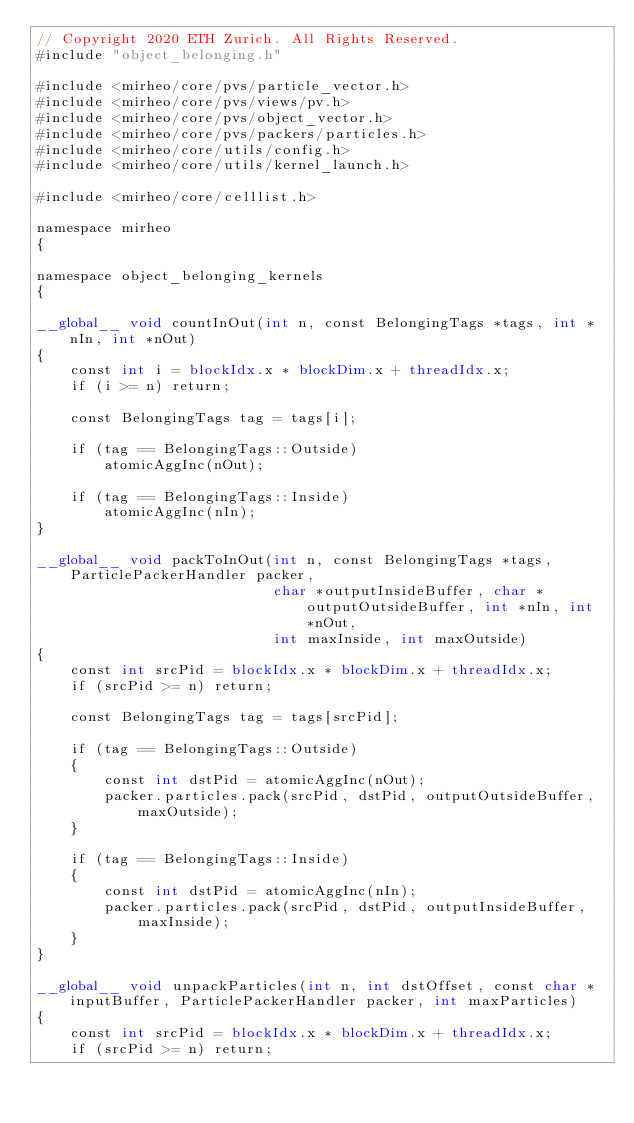<code> <loc_0><loc_0><loc_500><loc_500><_Cuda_>// Copyright 2020 ETH Zurich. All Rights Reserved.
#include "object_belonging.h"

#include <mirheo/core/pvs/particle_vector.h>
#include <mirheo/core/pvs/views/pv.h>
#include <mirheo/core/pvs/object_vector.h>
#include <mirheo/core/pvs/packers/particles.h>
#include <mirheo/core/utils/config.h>
#include <mirheo/core/utils/kernel_launch.h>

#include <mirheo/core/celllist.h>

namespace mirheo
{

namespace object_belonging_kernels
{

__global__ void countInOut(int n, const BelongingTags *tags, int *nIn, int *nOut)
{
    const int i = blockIdx.x * blockDim.x + threadIdx.x;
    if (i >= n) return;

    const BelongingTags tag = tags[i];

    if (tag == BelongingTags::Outside)
        atomicAggInc(nOut);

    if (tag == BelongingTags::Inside)
        atomicAggInc(nIn);
}

__global__ void packToInOut(int n, const BelongingTags *tags, ParticlePackerHandler packer,
                            char *outputInsideBuffer, char *outputOutsideBuffer, int *nIn, int *nOut,
                            int maxInside, int maxOutside)
{
    const int srcPid = blockIdx.x * blockDim.x + threadIdx.x;
    if (srcPid >= n) return;

    const BelongingTags tag = tags[srcPid];

    if (tag == BelongingTags::Outside)
    {
        const int dstPid = atomicAggInc(nOut);
        packer.particles.pack(srcPid, dstPid, outputOutsideBuffer, maxOutside);
    }

    if (tag == BelongingTags::Inside)
    {
        const int dstPid = atomicAggInc(nIn);
        packer.particles.pack(srcPid, dstPid, outputInsideBuffer, maxInside);
    }
}

__global__ void unpackParticles(int n, int dstOffset, const char *inputBuffer, ParticlePackerHandler packer, int maxParticles)
{
    const int srcPid = blockIdx.x * blockDim.x + threadIdx.x;
    if (srcPid >= n) return;</code> 